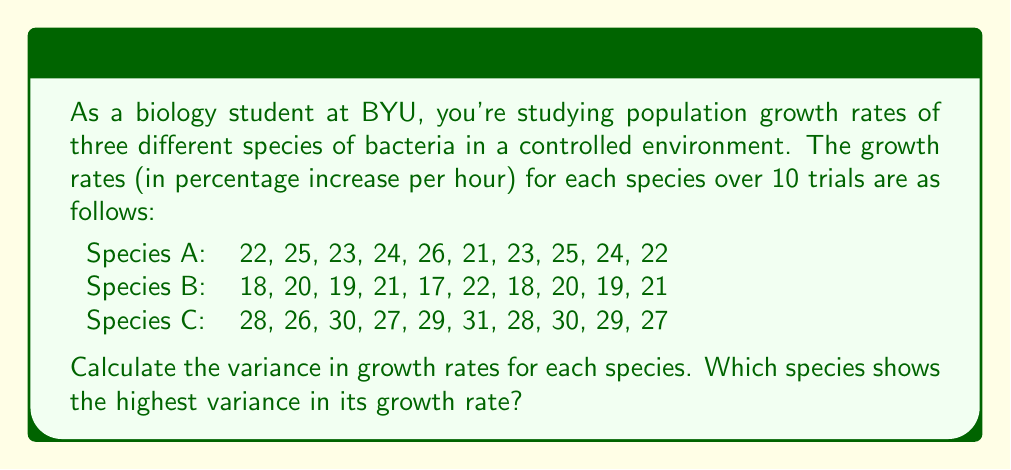Teach me how to tackle this problem. To solve this problem, we need to calculate the variance for each species' growth rates. The variance is a measure of variability in a dataset that can be calculated using the following formula:

$$ \text{Variance} = \frac{\sum_{i=1}^{n} (x_i - \bar{x})^2}{n - 1} $$

Where $x_i$ are the individual values, $\bar{x}$ is the mean, and $n$ is the number of values.

Let's calculate the variance for each species:

1. Species A:
   First, calculate the mean:
   $\bar{x}_A = \frac{22 + 25 + 23 + 24 + 26 + 21 + 23 + 25 + 24 + 22}{10} = 23.5$
   
   Now, calculate the variance:
   $$ \text{Variance}_A = \frac{(22-23.5)^2 + (25-23.5)^2 + ... + (22-23.5)^2}{9} = 2.28 $$

2. Species B:
   Mean: $\bar{x}_B = \frac{18 + 20 + 19 + 21 + 17 + 22 + 18 + 20 + 19 + 21}{10} = 19.5$
   
   Variance:
   $$ \text{Variance}_B = \frac{(18-19.5)^2 + (20-19.5)^2 + ... + (21-19.5)^2}{9} = 2.72 $$

3. Species C:
   Mean: $\bar{x}_C = \frac{28 + 26 + 30 + 27 + 29 + 31 + 28 + 30 + 29 + 27}{10} = 28.5$
   
   Variance:
   $$ \text{Variance}_C = \frac{(28-28.5)^2 + (26-28.5)^2 + ... + (27-28.5)^2}{9} = 2.50 $$

Comparing the variances:
Species A: 2.28
Species B: 2.72
Species C: 2.50

The highest variance is observed in Species B with a value of 2.72.
Answer: Species B (variance = 2.72) 